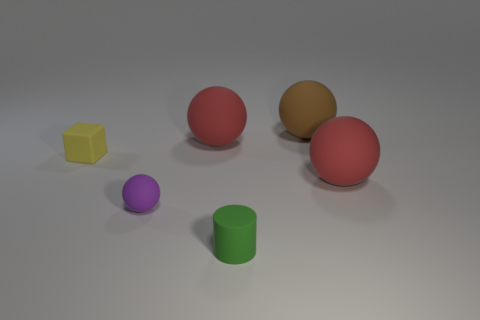What is the size of the brown rubber object that is the same shape as the purple rubber thing?
Your answer should be compact. Large. Are there any other things that are the same size as the green thing?
Your answer should be very brief. Yes. There is a red sphere to the left of the big red rubber ball that is to the right of the tiny green matte cylinder; what is its material?
Provide a succinct answer. Rubber. How many matte things are either cyan spheres or yellow cubes?
Your answer should be very brief. 1. There is another small object that is the same shape as the brown matte object; what is its color?
Offer a terse response. Purple. Is there a purple ball that is behind the red object that is behind the block?
Your answer should be very brief. No. What number of rubber objects are to the right of the small purple thing and behind the tiny rubber ball?
Your answer should be very brief. 3. What number of small purple spheres are the same material as the purple object?
Keep it short and to the point. 0. There is a red rubber object that is on the left side of the large red ball that is right of the tiny cylinder; what size is it?
Give a very brief answer. Large. Are there any big purple objects of the same shape as the green rubber object?
Your answer should be very brief. No. 